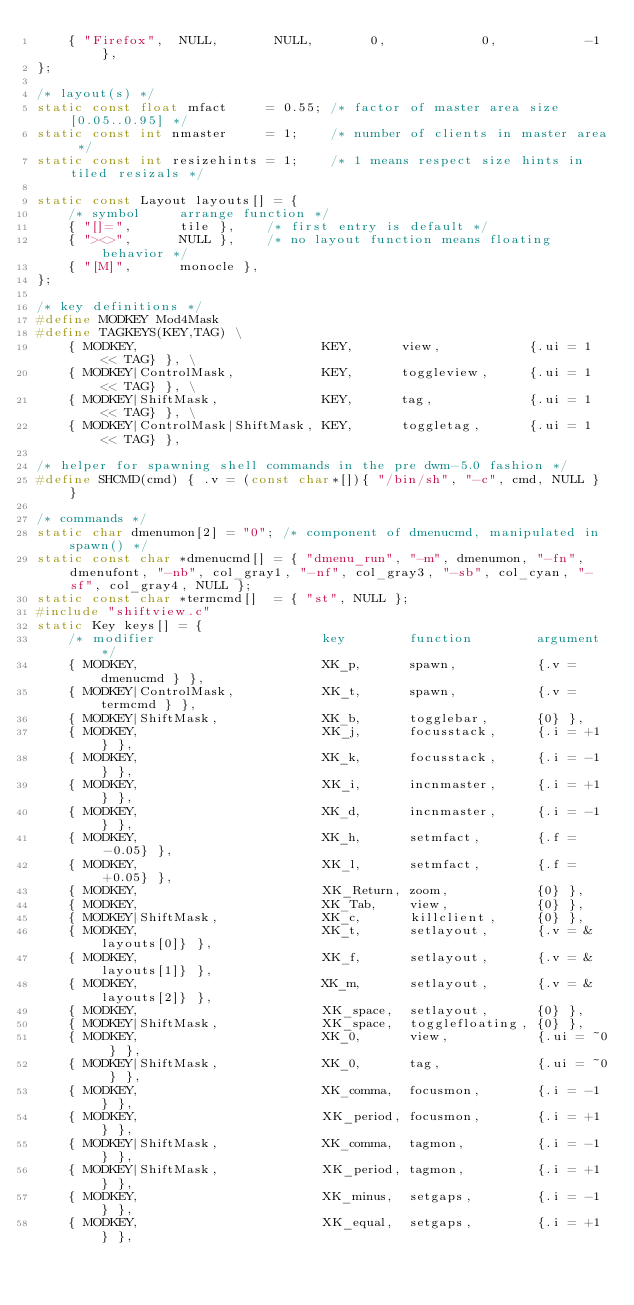<code> <loc_0><loc_0><loc_500><loc_500><_C_>	{ "Firefox",  NULL,       NULL,       0,            0,           -1 },
};

/* layout(s) */
static const float mfact     = 0.55; /* factor of master area size [0.05..0.95] */
static const int nmaster     = 1;    /* number of clients in master area */
static const int resizehints = 1;    /* 1 means respect size hints in tiled resizals */

static const Layout layouts[] = {
	/* symbol     arrange function */
	{ "[]=",      tile },    /* first entry is default */
	{ "><>",      NULL },    /* no layout function means floating behavior */
	{ "[M]",      monocle },
};

/* key definitions */
#define MODKEY Mod4Mask
#define TAGKEYS(KEY,TAG) \
	{ MODKEY,                       KEY,      view,           {.ui = 1 << TAG} }, \
	{ MODKEY|ControlMask,           KEY,      toggleview,     {.ui = 1 << TAG} }, \
	{ MODKEY|ShiftMask,             KEY,      tag,            {.ui = 1 << TAG} }, \
	{ MODKEY|ControlMask|ShiftMask, KEY,      toggletag,      {.ui = 1 << TAG} },

/* helper for spawning shell commands in the pre dwm-5.0 fashion */
#define SHCMD(cmd) { .v = (const char*[]){ "/bin/sh", "-c", cmd, NULL } }

/* commands */
static char dmenumon[2] = "0"; /* component of dmenucmd, manipulated in spawn() */
static const char *dmenucmd[] = { "dmenu_run", "-m", dmenumon, "-fn", dmenufont, "-nb", col_gray1, "-nf", col_gray3, "-sb", col_cyan, "-sf", col_gray4, NULL };
static const char *termcmd[]  = { "st", NULL };
#include "shiftview.c"
static Key keys[] = {
	/* modifier                     key        function        argument */
	{ MODKEY,                       XK_p,      spawn,          {.v = dmenucmd } },
	{ MODKEY|ControlMask,           XK_t,      spawn,          {.v = termcmd } },
	{ MODKEY|ShiftMask,             XK_b,      togglebar,      {0} },
	{ MODKEY,                       XK_j,      focusstack,     {.i = +1 } },
	{ MODKEY,                       XK_k,      focusstack,     {.i = -1 } },
	{ MODKEY,                       XK_i,      incnmaster,     {.i = +1 } },
	{ MODKEY,                       XK_d,      incnmaster,     {.i = -1 } },
	{ MODKEY,                       XK_h,      setmfact,       {.f = -0.05} },
	{ MODKEY,                       XK_l,      setmfact,       {.f = +0.05} },
	{ MODKEY,                       XK_Return, zoom,           {0} },
	{ MODKEY,                       XK_Tab,    view,           {0} },
	{ MODKEY|ShiftMask,             XK_c,      killclient,     {0} },
	{ MODKEY,                       XK_t,      setlayout,      {.v = &layouts[0]} },
	{ MODKEY,                       XK_f,      setlayout,      {.v = &layouts[1]} },
	{ MODKEY,                       XK_m,      setlayout,      {.v = &layouts[2]} },
	{ MODKEY,                       XK_space,  setlayout,      {0} },
	{ MODKEY|ShiftMask,             XK_space,  togglefloating, {0} },
	{ MODKEY,                       XK_0,      view,           {.ui = ~0 } },
	{ MODKEY|ShiftMask,             XK_0,      tag,            {.ui = ~0 } },
	{ MODKEY,                       XK_comma,  focusmon,       {.i = -1 } },
	{ MODKEY,                       XK_period, focusmon,       {.i = +1 } },
	{ MODKEY|ShiftMask,             XK_comma,  tagmon,         {.i = -1 } },
	{ MODKEY|ShiftMask,             XK_period, tagmon,         {.i = +1 } },
	{ MODKEY,                       XK_minus,  setgaps,        {.i = -1 } },
	{ MODKEY,                       XK_equal,  setgaps,        {.i = +1 } },</code> 